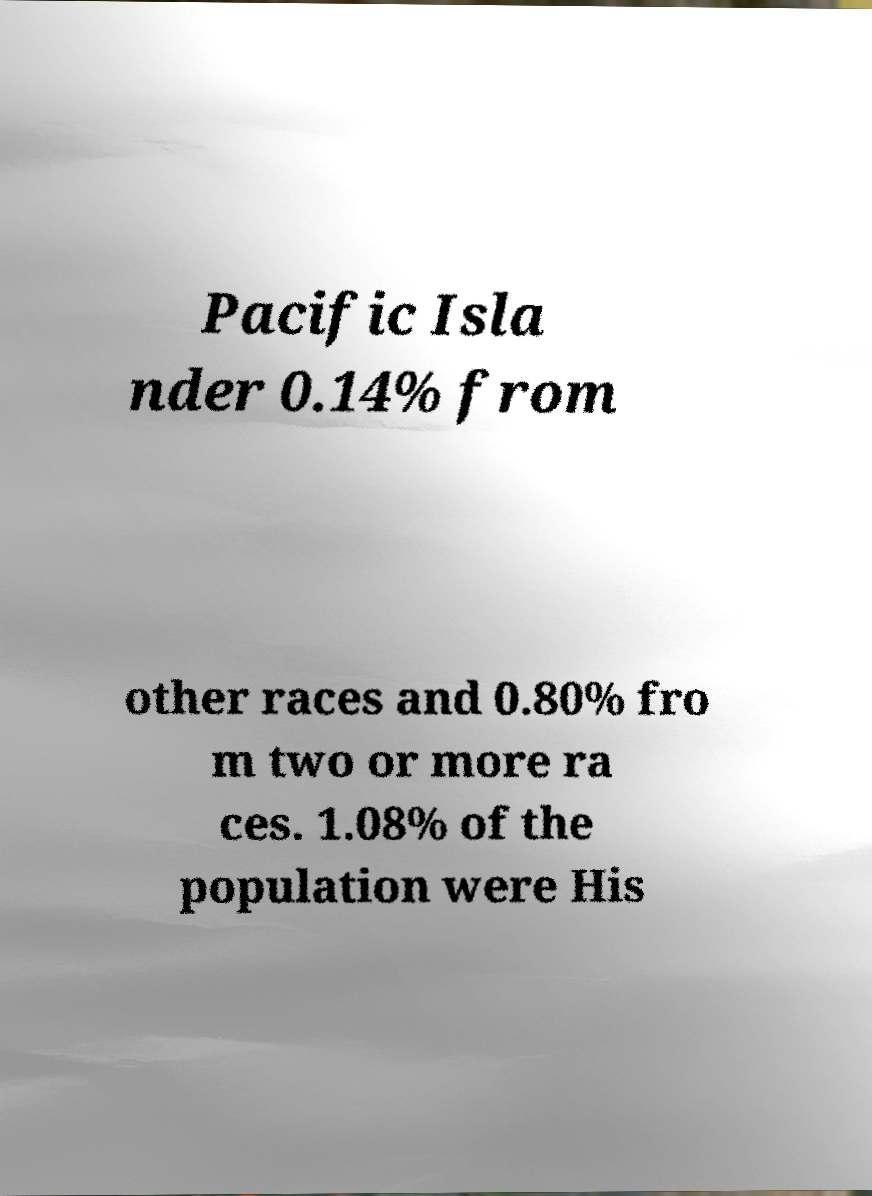What messages or text are displayed in this image? I need them in a readable, typed format. Pacific Isla nder 0.14% from other races and 0.80% fro m two or more ra ces. 1.08% of the population were His 